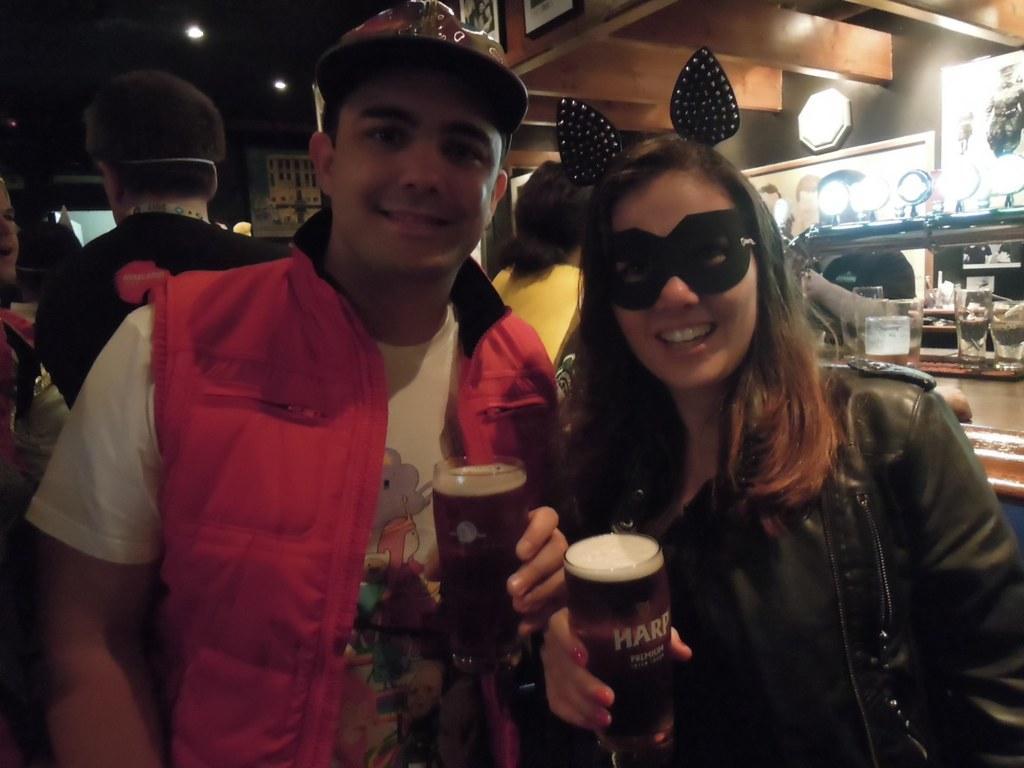Could you give a brief overview of what you see in this image? In this image i can see a man wearing a hat, white t shirt and red jacket and a woman Wearing a black mask and black jacket are holding glasses of beer in their hands. In the back =ground i can see few persons, the ceiling, few lights and few glasses. 